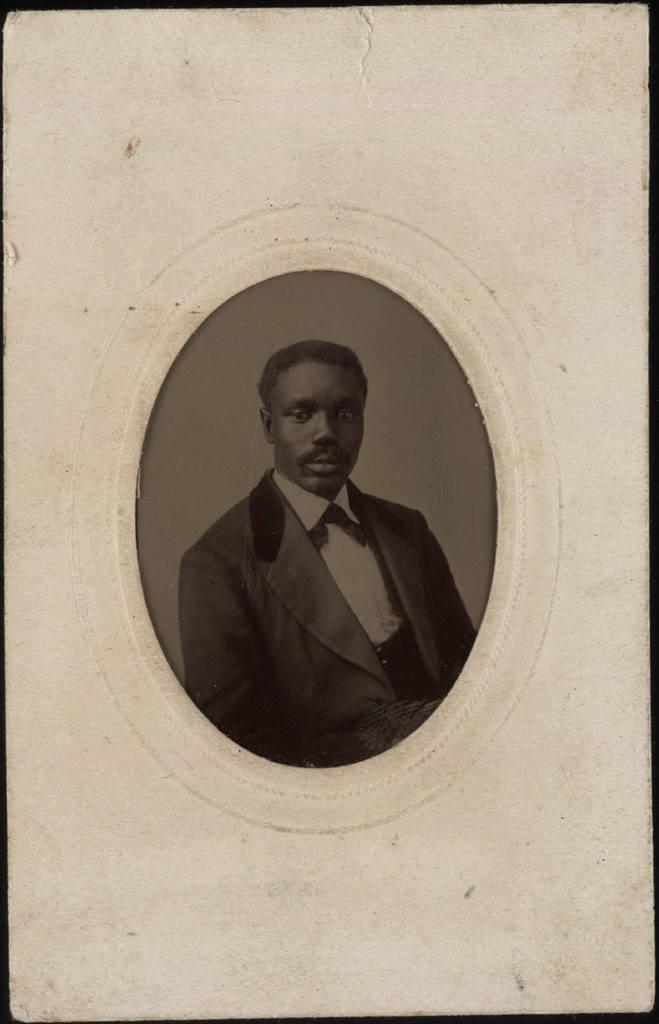What is the color scheme of the image? The image is black and white. Who is present in the image? There is a man in a suit in the image. What type of image is this? The man is in a photograph. What is the background of the image? There is a white background in the image. What type of blade is the man holding in the image? There is no blade present in the image; the man is simply standing in a photograph. 